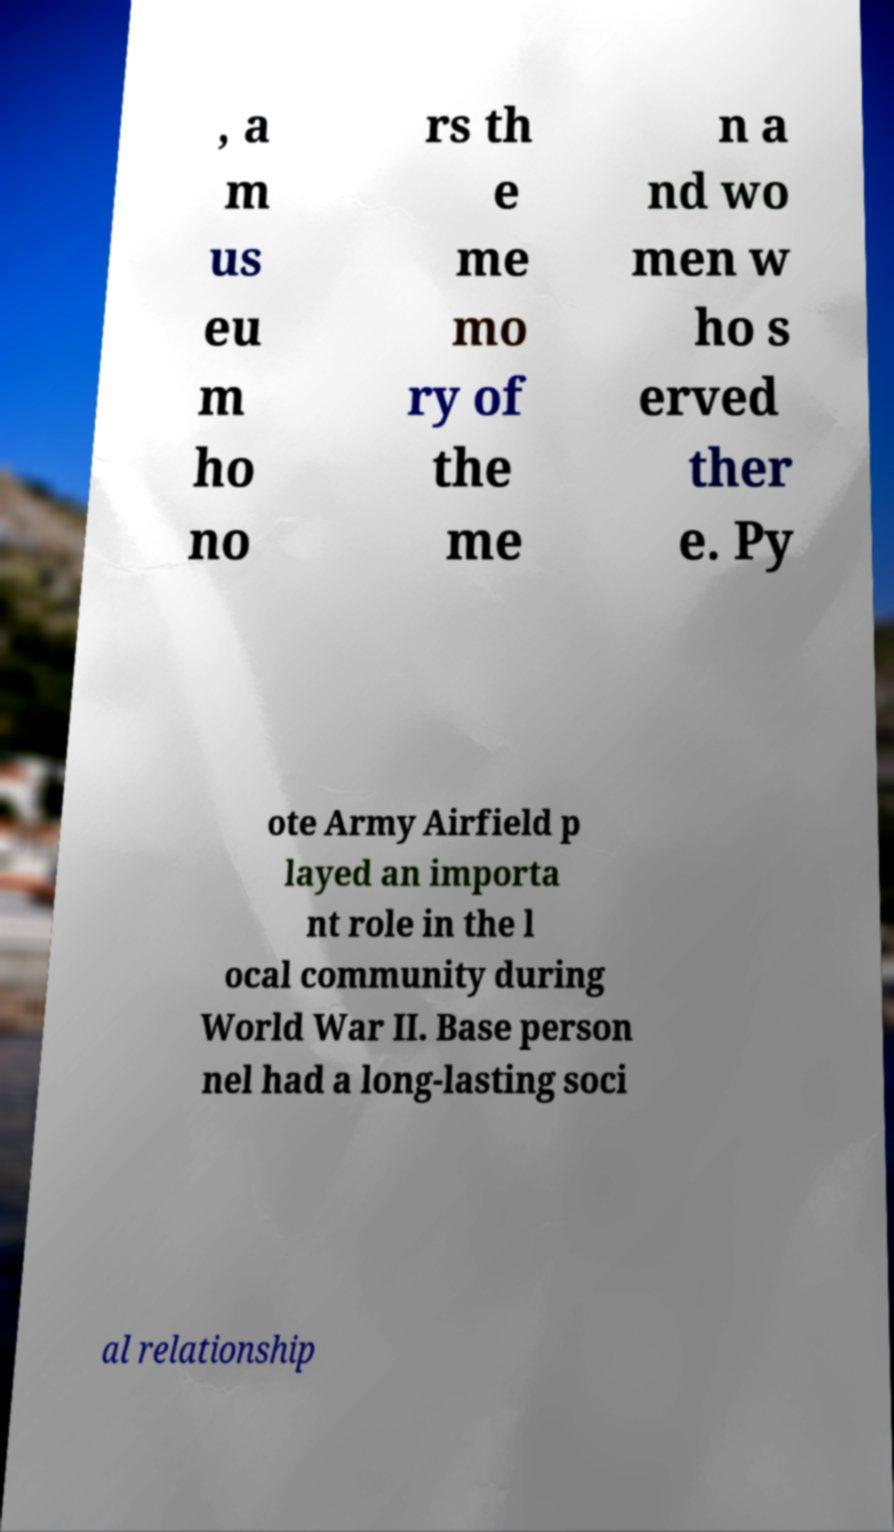Can you read and provide the text displayed in the image?This photo seems to have some interesting text. Can you extract and type it out for me? , a m us eu m ho no rs th e me mo ry of the me n a nd wo men w ho s erved ther e. Py ote Army Airfield p layed an importa nt role in the l ocal community during World War II. Base person nel had a long-lasting soci al relationship 